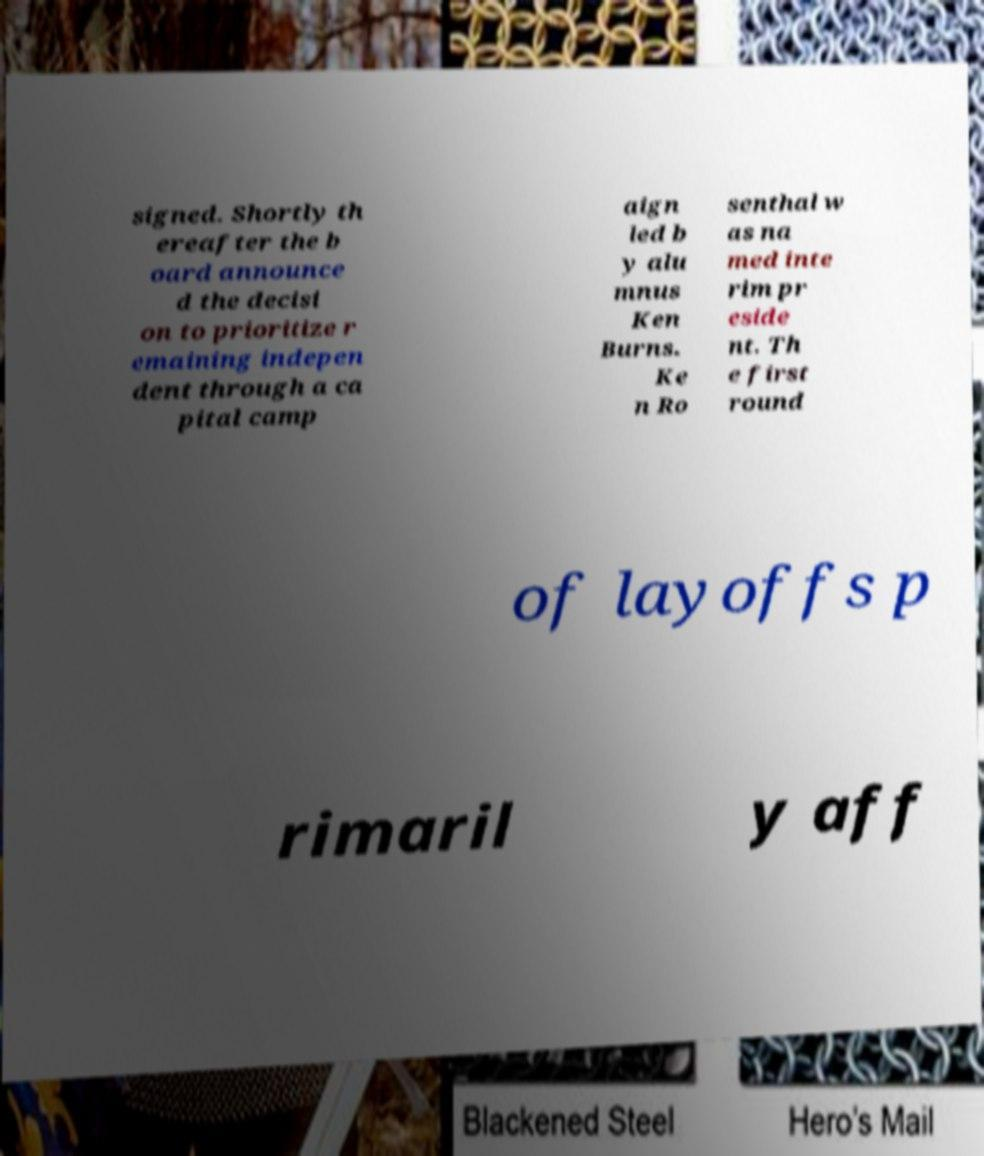Could you assist in decoding the text presented in this image and type it out clearly? signed. Shortly th ereafter the b oard announce d the decisi on to prioritize r emaining indepen dent through a ca pital camp aign led b y alu mnus Ken Burns. Ke n Ro senthal w as na med inte rim pr eside nt. Th e first round of layoffs p rimaril y aff 